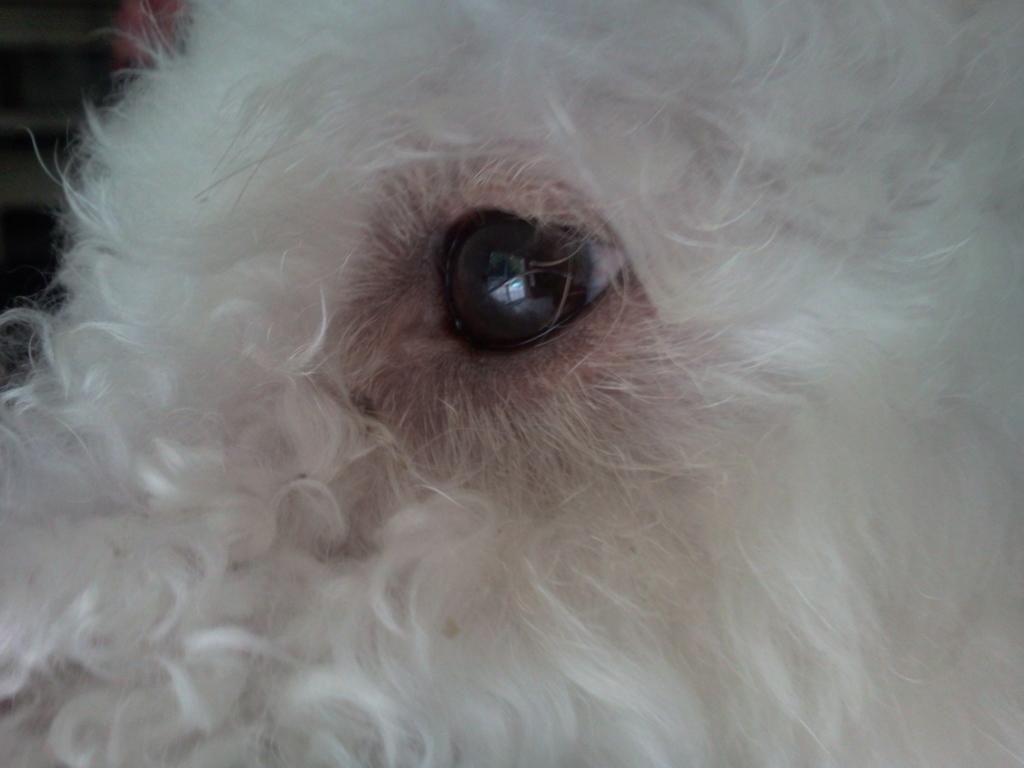In one or two sentences, can you explain what this image depicts? In this picture there is a dog eye. 